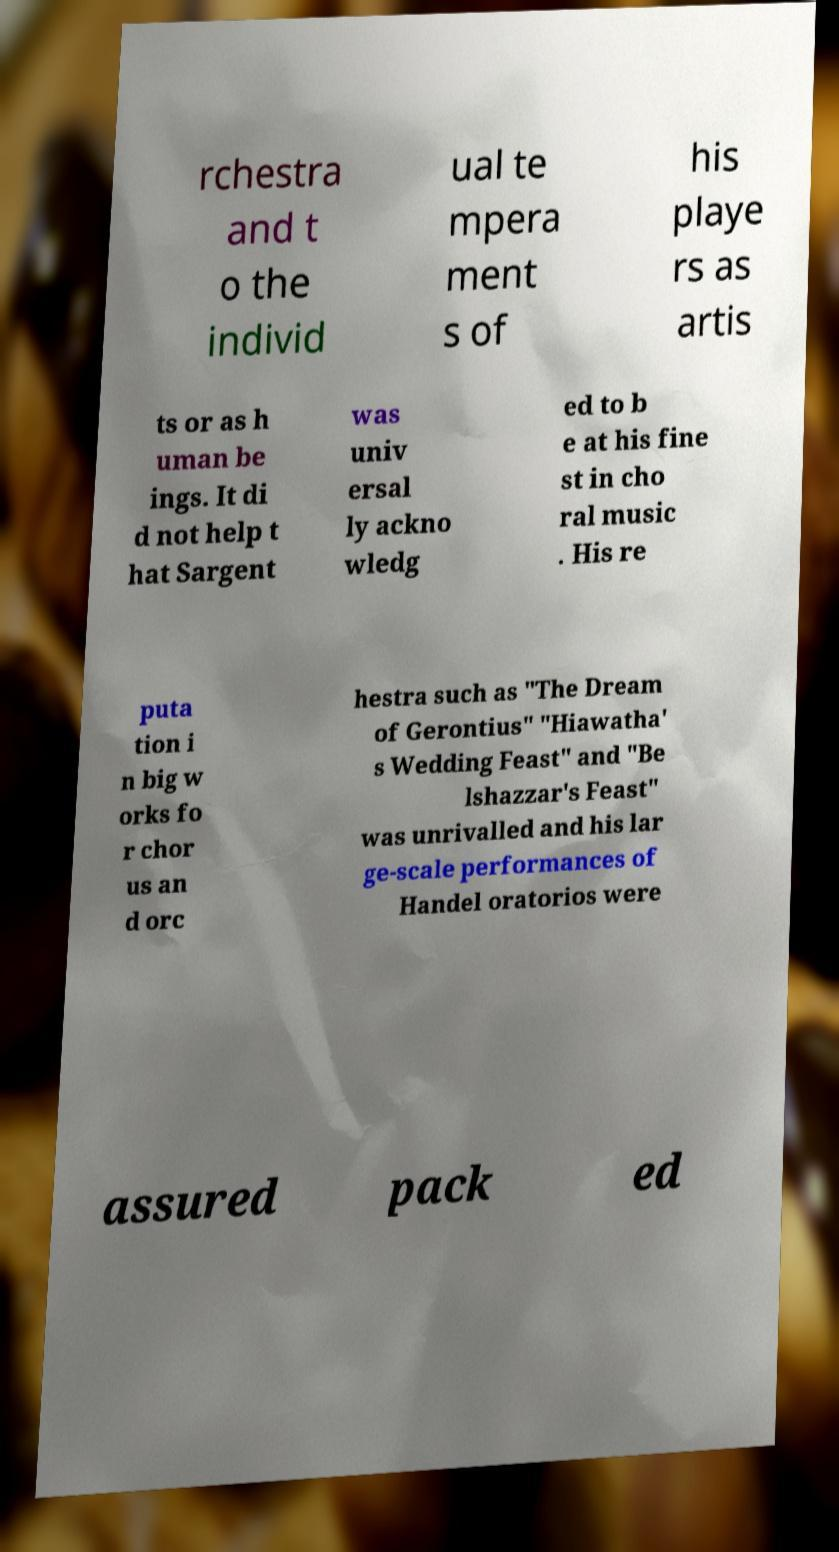Could you extract and type out the text from this image? rchestra and t o the individ ual te mpera ment s of his playe rs as artis ts or as h uman be ings. It di d not help t hat Sargent was univ ersal ly ackno wledg ed to b e at his fine st in cho ral music . His re puta tion i n big w orks fo r chor us an d orc hestra such as "The Dream of Gerontius" "Hiawatha' s Wedding Feast" and "Be lshazzar's Feast" was unrivalled and his lar ge-scale performances of Handel oratorios were assured pack ed 